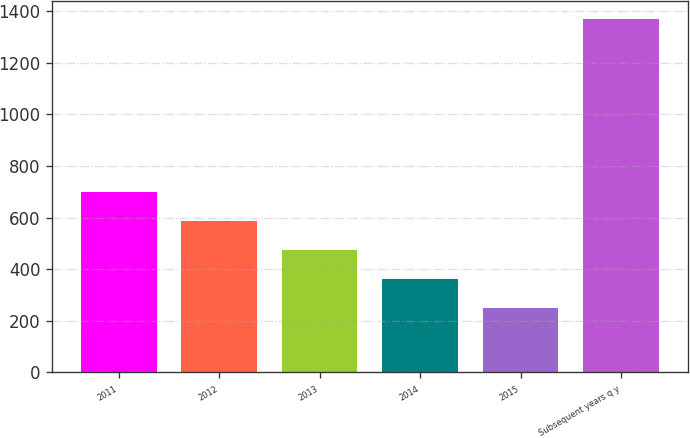<chart> <loc_0><loc_0><loc_500><loc_500><bar_chart><fcel>2011<fcel>2012<fcel>2013<fcel>2014<fcel>2015<fcel>Subsequent years q y<nl><fcel>697.8<fcel>585.6<fcel>473.4<fcel>361.2<fcel>249<fcel>1371<nl></chart> 